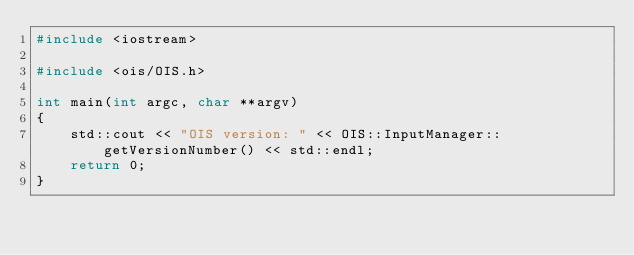Convert code to text. <code><loc_0><loc_0><loc_500><loc_500><_C++_>#include <iostream>

#include <ois/OIS.h>

int main(int argc, char **argv)
{
    std::cout << "OIS version: " << OIS::InputManager::getVersionNumber() << std::endl;
    return 0;
}
</code> 